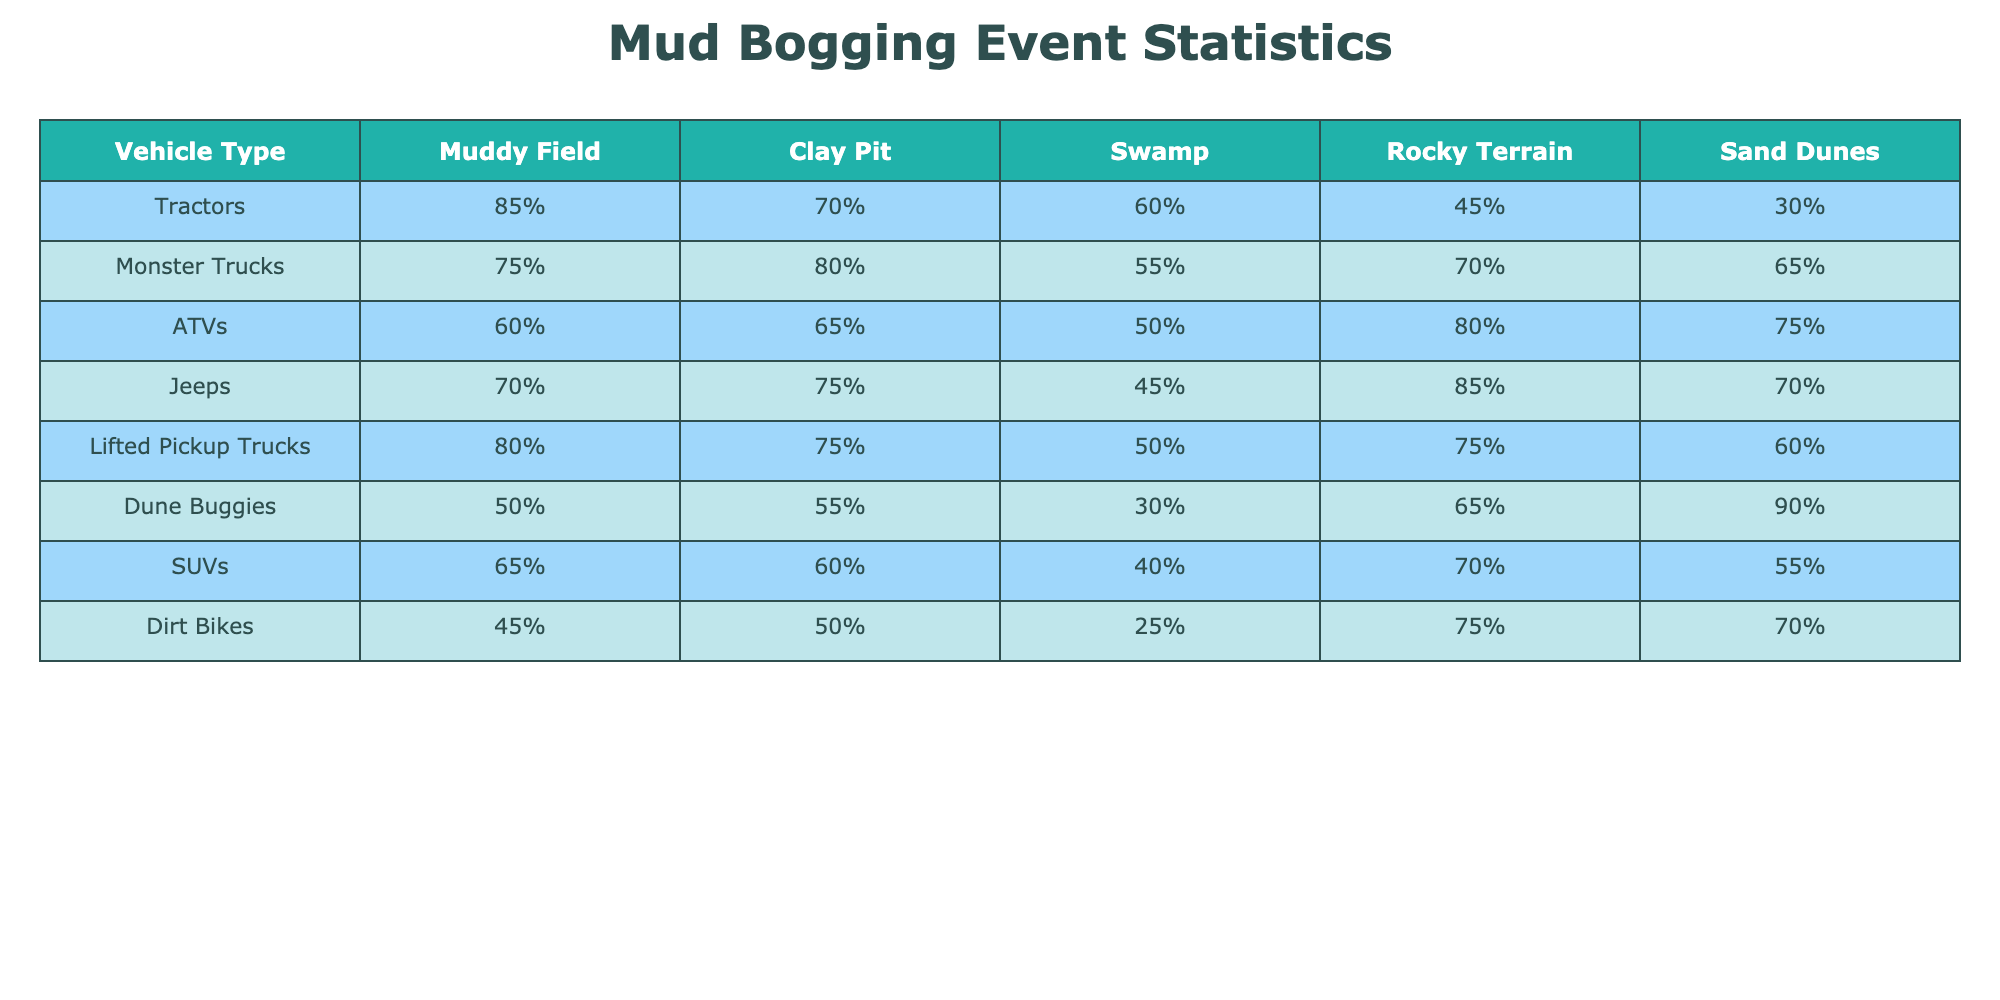What is the percentage of tractors that perform well in a muddy field? The table shows that tractors have an 85% success rate in a muddy field.
Answer: 85% Which vehicle type has the lowest performance in the swamp? From the table, dune buggies have the lowest performance in the swamp at 30%.
Answer: Dune Buggies What is the performance difference between ATVs and monster trucks in rocky terrain? ATVs perform at 80% and monster trucks at 70%, so the difference is 80% - 70% = 10%.
Answer: 10% Do lifted pickup trucks perform better than ATVs in sand dunes? Lifted pickup trucks have a 60% performance rate and ATVs have a 75% performance rate, which means lifted pickup trucks do not perform better.
Answer: No What is the average performance of jeeps across all terrain types? The performance percentages for jeeps are 70%, 75%, 45%, 85%, and 70%. The average is (70 + 75 + 45 + 85 + 70) / 5 = 67%.
Answer: 67% Which vehicle type performs best in rocky terrain? In rocky terrain, the table shows that jeeps have the highest performance at 85%.
Answer: Jeeps Is there any vehicle type that performs equally well in both the muddy field and clay pit? The performance rates show that both monster trucks and lifted pickup trucks perform equally well in the muddy field (75%) and clay pit (75%).
Answer: Yes What is the total percentage performance of SUVs in muddy field and swamp combined? The performance for SUVs is 65% in a muddy field and 40% in a swamp, so the total is 65% + 40% = 105%.
Answer: 105% Which vehicle type has the second best performance in sand dunes? The table indicates that dune buggies have the highest performance at 90%, followed by monster trucks at 65%.
Answer: Monster Trucks What percentage do dirt bikes achieve in the muddy field compared to their performance in the swamp? Dirt bikes have 45% in the muddy field and 25% in the swamp, resulting in a difference of 45% - 25% = 20%.
Answer: 20% 